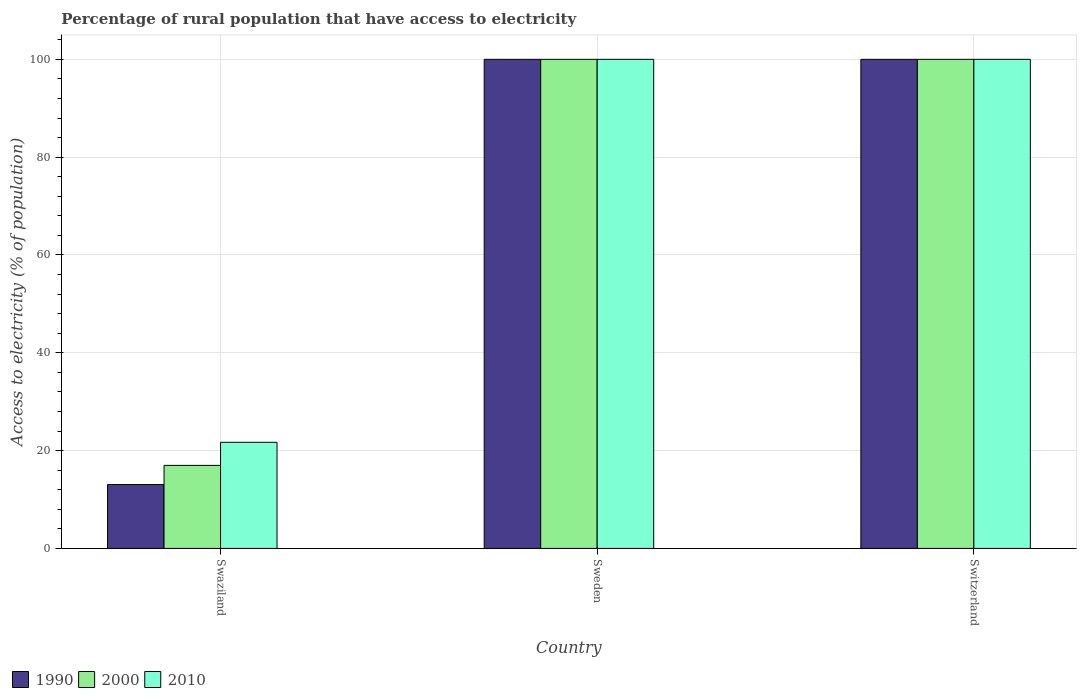How many different coloured bars are there?
Your answer should be very brief. 3. How many groups of bars are there?
Your answer should be compact. 3. Are the number of bars per tick equal to the number of legend labels?
Ensure brevity in your answer.  Yes. What is the label of the 2nd group of bars from the left?
Your response must be concise. Sweden. In how many cases, is the number of bars for a given country not equal to the number of legend labels?
Offer a terse response. 0. What is the percentage of rural population that have access to electricity in 1990 in Swaziland?
Provide a succinct answer. 13.06. Across all countries, what is the minimum percentage of rural population that have access to electricity in 1990?
Your answer should be very brief. 13.06. In which country was the percentage of rural population that have access to electricity in 2010 minimum?
Provide a succinct answer. Swaziland. What is the total percentage of rural population that have access to electricity in 2010 in the graph?
Your answer should be compact. 221.7. What is the difference between the percentage of rural population that have access to electricity in 2010 in Swaziland and that in Switzerland?
Provide a succinct answer. -78.3. What is the difference between the percentage of rural population that have access to electricity in 2000 in Switzerland and the percentage of rural population that have access to electricity in 2010 in Swaziland?
Give a very brief answer. 78.3. What is the average percentage of rural population that have access to electricity in 2000 per country?
Your answer should be very brief. 72.33. In how many countries, is the percentage of rural population that have access to electricity in 2000 greater than 80 %?
Offer a terse response. 2. What is the ratio of the percentage of rural population that have access to electricity in 2010 in Swaziland to that in Switzerland?
Provide a short and direct response. 0.22. Is the percentage of rural population that have access to electricity in 2010 in Swaziland less than that in Sweden?
Your response must be concise. Yes. What is the difference between the highest and the second highest percentage of rural population that have access to electricity in 2000?
Provide a short and direct response. -83.02. What is the difference between the highest and the lowest percentage of rural population that have access to electricity in 2000?
Your response must be concise. 83.02. In how many countries, is the percentage of rural population that have access to electricity in 1990 greater than the average percentage of rural population that have access to electricity in 1990 taken over all countries?
Keep it short and to the point. 2. What does the 1st bar from the left in Switzerland represents?
Ensure brevity in your answer.  1990. How many countries are there in the graph?
Keep it short and to the point. 3. Does the graph contain grids?
Your response must be concise. Yes. Where does the legend appear in the graph?
Your response must be concise. Bottom left. How are the legend labels stacked?
Offer a very short reply. Horizontal. What is the title of the graph?
Your response must be concise. Percentage of rural population that have access to electricity. Does "1960" appear as one of the legend labels in the graph?
Keep it short and to the point. No. What is the label or title of the Y-axis?
Offer a terse response. Access to electricity (% of population). What is the Access to electricity (% of population) in 1990 in Swaziland?
Provide a short and direct response. 13.06. What is the Access to electricity (% of population) of 2000 in Swaziland?
Offer a very short reply. 16.98. What is the Access to electricity (% of population) in 2010 in Swaziland?
Your response must be concise. 21.7. What is the Access to electricity (% of population) in 2000 in Switzerland?
Ensure brevity in your answer.  100. Across all countries, what is the maximum Access to electricity (% of population) in 1990?
Your answer should be very brief. 100. Across all countries, what is the maximum Access to electricity (% of population) of 2000?
Provide a succinct answer. 100. Across all countries, what is the minimum Access to electricity (% of population) of 1990?
Keep it short and to the point. 13.06. Across all countries, what is the minimum Access to electricity (% of population) of 2000?
Ensure brevity in your answer.  16.98. Across all countries, what is the minimum Access to electricity (% of population) in 2010?
Provide a succinct answer. 21.7. What is the total Access to electricity (% of population) in 1990 in the graph?
Ensure brevity in your answer.  213.06. What is the total Access to electricity (% of population) in 2000 in the graph?
Make the answer very short. 216.98. What is the total Access to electricity (% of population) of 2010 in the graph?
Your answer should be compact. 221.7. What is the difference between the Access to electricity (% of population) in 1990 in Swaziland and that in Sweden?
Your answer should be very brief. -86.94. What is the difference between the Access to electricity (% of population) in 2000 in Swaziland and that in Sweden?
Your response must be concise. -83.02. What is the difference between the Access to electricity (% of population) of 2010 in Swaziland and that in Sweden?
Offer a terse response. -78.3. What is the difference between the Access to electricity (% of population) of 1990 in Swaziland and that in Switzerland?
Your answer should be very brief. -86.94. What is the difference between the Access to electricity (% of population) in 2000 in Swaziland and that in Switzerland?
Make the answer very short. -83.02. What is the difference between the Access to electricity (% of population) of 2010 in Swaziland and that in Switzerland?
Provide a short and direct response. -78.3. What is the difference between the Access to electricity (% of population) of 1990 in Sweden and that in Switzerland?
Your answer should be very brief. 0. What is the difference between the Access to electricity (% of population) in 2010 in Sweden and that in Switzerland?
Your answer should be very brief. 0. What is the difference between the Access to electricity (% of population) of 1990 in Swaziland and the Access to electricity (% of population) of 2000 in Sweden?
Your answer should be compact. -86.94. What is the difference between the Access to electricity (% of population) of 1990 in Swaziland and the Access to electricity (% of population) of 2010 in Sweden?
Your response must be concise. -86.94. What is the difference between the Access to electricity (% of population) in 2000 in Swaziland and the Access to electricity (% of population) in 2010 in Sweden?
Give a very brief answer. -83.02. What is the difference between the Access to electricity (% of population) in 1990 in Swaziland and the Access to electricity (% of population) in 2000 in Switzerland?
Your answer should be compact. -86.94. What is the difference between the Access to electricity (% of population) of 1990 in Swaziland and the Access to electricity (% of population) of 2010 in Switzerland?
Your response must be concise. -86.94. What is the difference between the Access to electricity (% of population) of 2000 in Swaziland and the Access to electricity (% of population) of 2010 in Switzerland?
Make the answer very short. -83.02. What is the difference between the Access to electricity (% of population) of 2000 in Sweden and the Access to electricity (% of population) of 2010 in Switzerland?
Your answer should be compact. 0. What is the average Access to electricity (% of population) in 1990 per country?
Your answer should be very brief. 71.02. What is the average Access to electricity (% of population) of 2000 per country?
Your answer should be very brief. 72.33. What is the average Access to electricity (% of population) in 2010 per country?
Your answer should be compact. 73.9. What is the difference between the Access to electricity (% of population) in 1990 and Access to electricity (% of population) in 2000 in Swaziland?
Keep it short and to the point. -3.92. What is the difference between the Access to electricity (% of population) in 1990 and Access to electricity (% of population) in 2010 in Swaziland?
Give a very brief answer. -8.64. What is the difference between the Access to electricity (% of population) of 2000 and Access to electricity (% of population) of 2010 in Swaziland?
Your answer should be very brief. -4.72. What is the difference between the Access to electricity (% of population) of 1990 and Access to electricity (% of population) of 2010 in Sweden?
Your response must be concise. 0. What is the difference between the Access to electricity (% of population) in 1990 and Access to electricity (% of population) in 2000 in Switzerland?
Provide a short and direct response. 0. What is the difference between the Access to electricity (% of population) of 1990 and Access to electricity (% of population) of 2010 in Switzerland?
Offer a very short reply. 0. What is the ratio of the Access to electricity (% of population) of 1990 in Swaziland to that in Sweden?
Give a very brief answer. 0.13. What is the ratio of the Access to electricity (% of population) of 2000 in Swaziland to that in Sweden?
Give a very brief answer. 0.17. What is the ratio of the Access to electricity (% of population) of 2010 in Swaziland to that in Sweden?
Keep it short and to the point. 0.22. What is the ratio of the Access to electricity (% of population) of 1990 in Swaziland to that in Switzerland?
Make the answer very short. 0.13. What is the ratio of the Access to electricity (% of population) of 2000 in Swaziland to that in Switzerland?
Provide a short and direct response. 0.17. What is the ratio of the Access to electricity (% of population) in 2010 in Swaziland to that in Switzerland?
Give a very brief answer. 0.22. What is the ratio of the Access to electricity (% of population) in 1990 in Sweden to that in Switzerland?
Offer a very short reply. 1. What is the ratio of the Access to electricity (% of population) in 2000 in Sweden to that in Switzerland?
Give a very brief answer. 1. What is the ratio of the Access to electricity (% of population) of 2010 in Sweden to that in Switzerland?
Your answer should be very brief. 1. What is the difference between the highest and the second highest Access to electricity (% of population) in 1990?
Your answer should be very brief. 0. What is the difference between the highest and the lowest Access to electricity (% of population) in 1990?
Your answer should be compact. 86.94. What is the difference between the highest and the lowest Access to electricity (% of population) in 2000?
Offer a very short reply. 83.02. What is the difference between the highest and the lowest Access to electricity (% of population) of 2010?
Your answer should be compact. 78.3. 